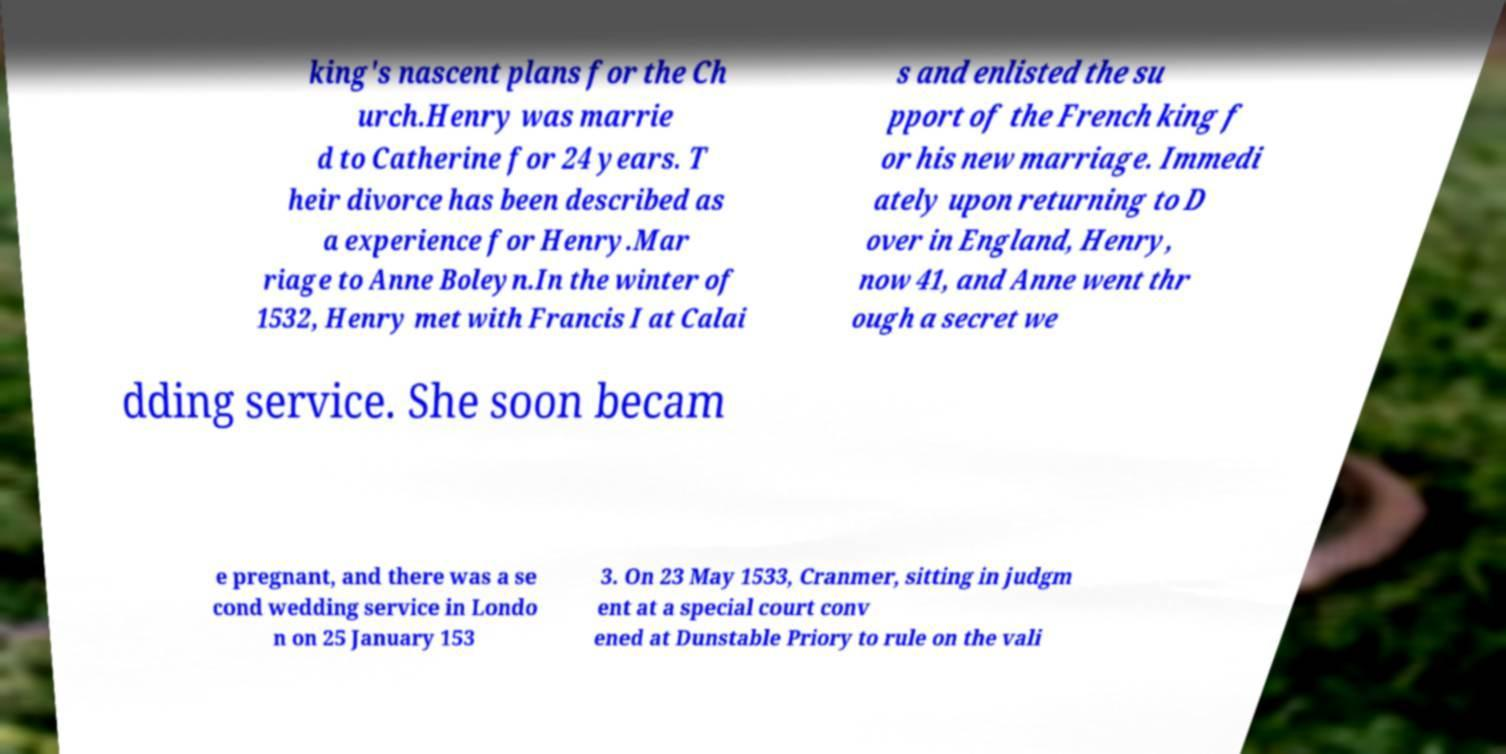Could you extract and type out the text from this image? king's nascent plans for the Ch urch.Henry was marrie d to Catherine for 24 years. T heir divorce has been described as a experience for Henry.Mar riage to Anne Boleyn.In the winter of 1532, Henry met with Francis I at Calai s and enlisted the su pport of the French king f or his new marriage. Immedi ately upon returning to D over in England, Henry, now 41, and Anne went thr ough a secret we dding service. She soon becam e pregnant, and there was a se cond wedding service in Londo n on 25 January 153 3. On 23 May 1533, Cranmer, sitting in judgm ent at a special court conv ened at Dunstable Priory to rule on the vali 